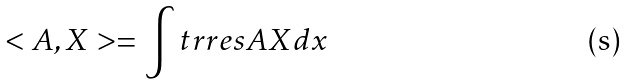Convert formula to latex. <formula><loc_0><loc_0><loc_500><loc_500>< A , X > = \int t r r e s A X d x</formula> 